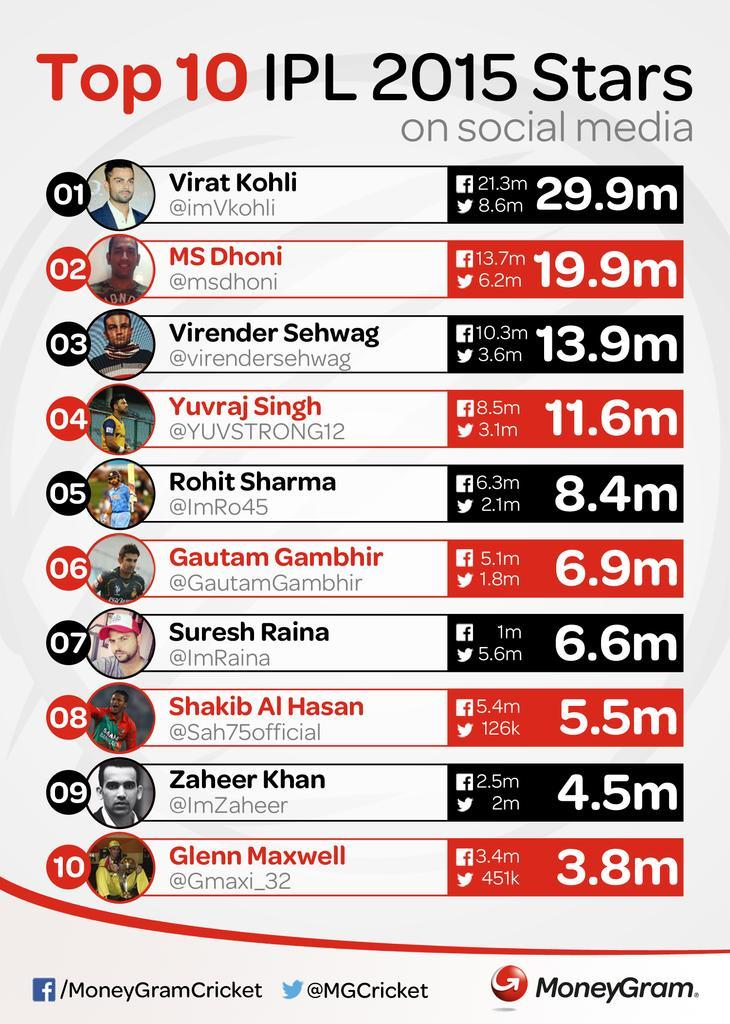WHo has the second least following in Twitter
Answer the question with a short phrase. Glenn Maxwell How many followers in twitter for Virat KOhli 8.6m WHat is Yuvraj Singh's twitter follower count 3.1m All these players are from which sports, cricket or football cricket How many more million followers than Dhoni does Virat Kohli have in Twitter 2.4 Who has more followers in Twitter than in Facebook Suresh Raina 